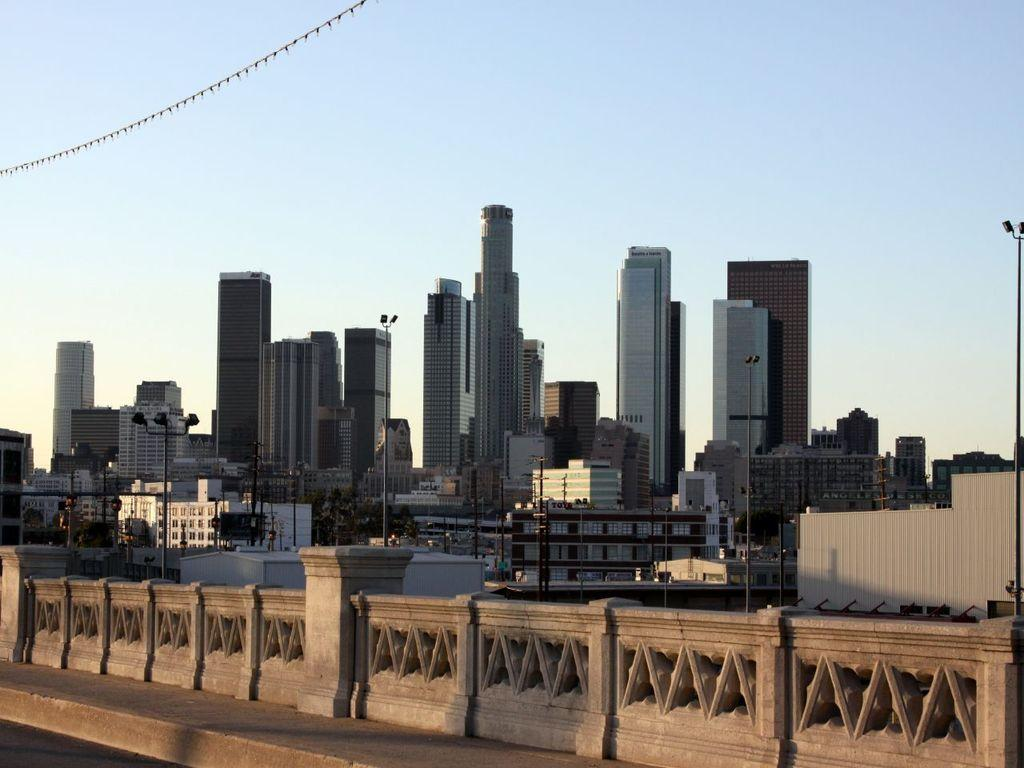What can be seen in the foreground of the image? There is a railing in the image. What is visible in the background of the image? There are many tall buildings behind the railing. Are there any other structures or objects visible in the image? Yes, there are poles visible in the image. What type of apparel is the railing wearing in the image? The railing is not a living being and does not wear apparel. --- 